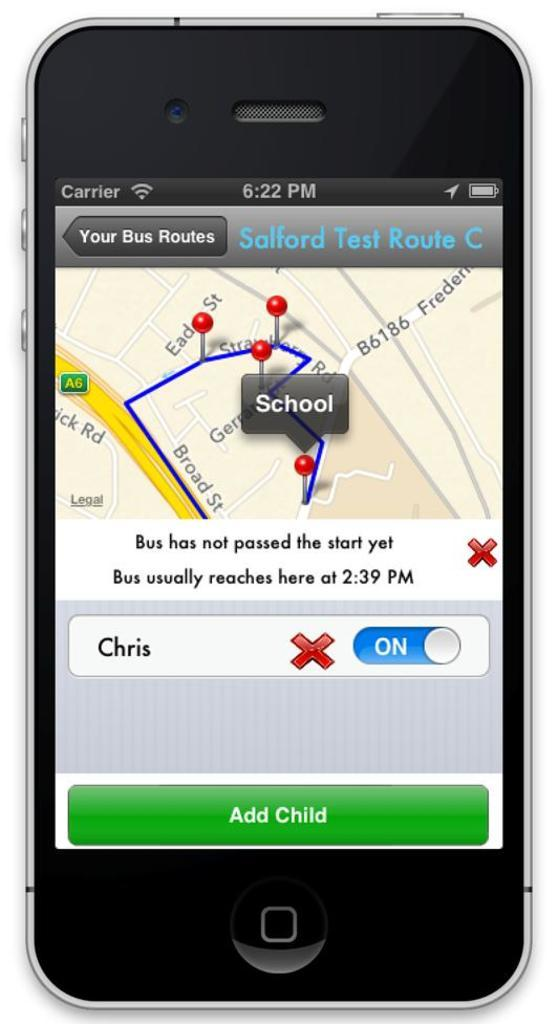<image>
Provide a brief description of the given image. Phone screen showing different bus routes for children. 